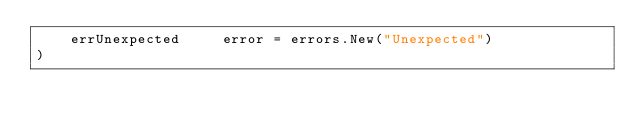<code> <loc_0><loc_0><loc_500><loc_500><_Go_>	errUnexpected     error = errors.New("Unexpected")
)
</code> 